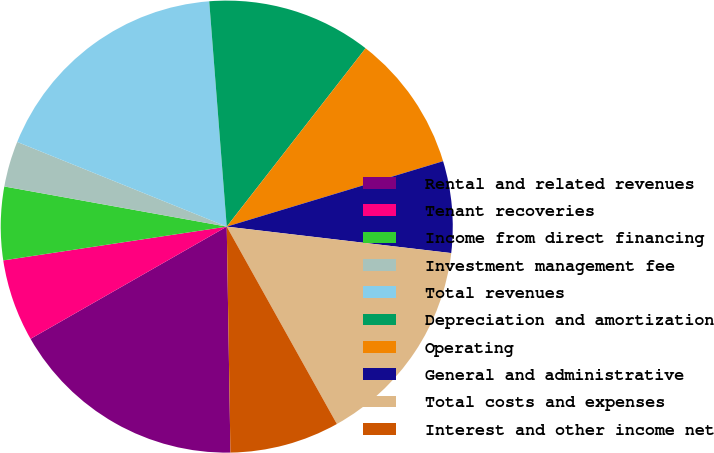Convert chart to OTSL. <chart><loc_0><loc_0><loc_500><loc_500><pie_chart><fcel>Rental and related revenues<fcel>Tenant recoveries<fcel>Income from direct financing<fcel>Investment management fee<fcel>Total revenues<fcel>Depreciation and amortization<fcel>Operating<fcel>General and administrative<fcel>Total costs and expenses<fcel>Interest and other income net<nl><fcel>16.99%<fcel>5.88%<fcel>5.23%<fcel>3.27%<fcel>17.65%<fcel>11.76%<fcel>9.8%<fcel>6.54%<fcel>15.03%<fcel>7.84%<nl></chart> 